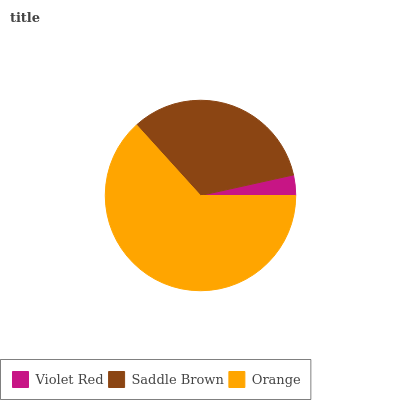Is Violet Red the minimum?
Answer yes or no. Yes. Is Orange the maximum?
Answer yes or no. Yes. Is Saddle Brown the minimum?
Answer yes or no. No. Is Saddle Brown the maximum?
Answer yes or no. No. Is Saddle Brown greater than Violet Red?
Answer yes or no. Yes. Is Violet Red less than Saddle Brown?
Answer yes or no. Yes. Is Violet Red greater than Saddle Brown?
Answer yes or no. No. Is Saddle Brown less than Violet Red?
Answer yes or no. No. Is Saddle Brown the high median?
Answer yes or no. Yes. Is Saddle Brown the low median?
Answer yes or no. Yes. Is Orange the high median?
Answer yes or no. No. Is Orange the low median?
Answer yes or no. No. 